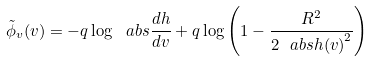Convert formula to latex. <formula><loc_0><loc_0><loc_500><loc_500>\tilde { \phi } _ { v } ( v ) = - q \log { \ a b s { \frac { d h } { d v } } } + q \log \left ( 1 - \frac { R ^ { 2 } } { 2 \ a b s { h ( v ) } ^ { 2 } } \right )</formula> 